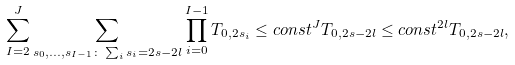<formula> <loc_0><loc_0><loc_500><loc_500>\sum _ { I = 2 } ^ { J } \sum _ { s _ { 0 } , \dots , s _ { I - 1 } \colon \sum _ { i } s _ { i } = 2 s - 2 l } \prod _ { i = 0 } ^ { I - 1 } T _ { 0 , 2 s _ { i } } \leq c o n s t ^ { J } T _ { 0 , 2 s - 2 l } \leq c o n s t ^ { 2 l } T _ { 0 , 2 s - 2 l } ,</formula> 